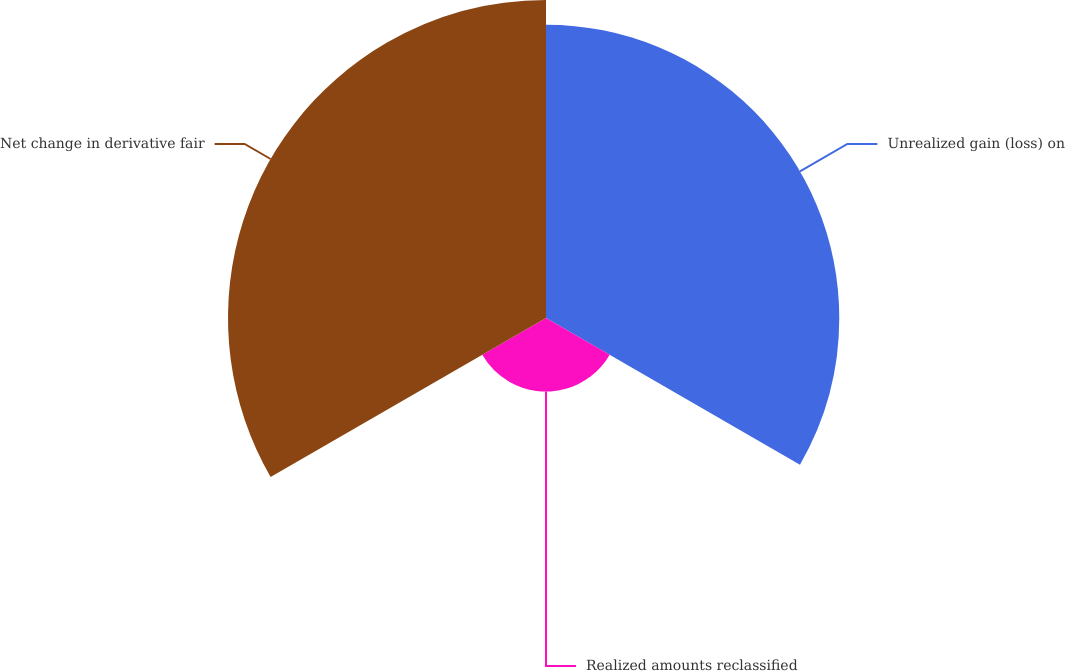<chart> <loc_0><loc_0><loc_500><loc_500><pie_chart><fcel>Unrealized gain (loss) on<fcel>Realized amounts reclassified<fcel>Net change in derivative fair<nl><fcel>42.82%<fcel>10.74%<fcel>46.43%<nl></chart> 